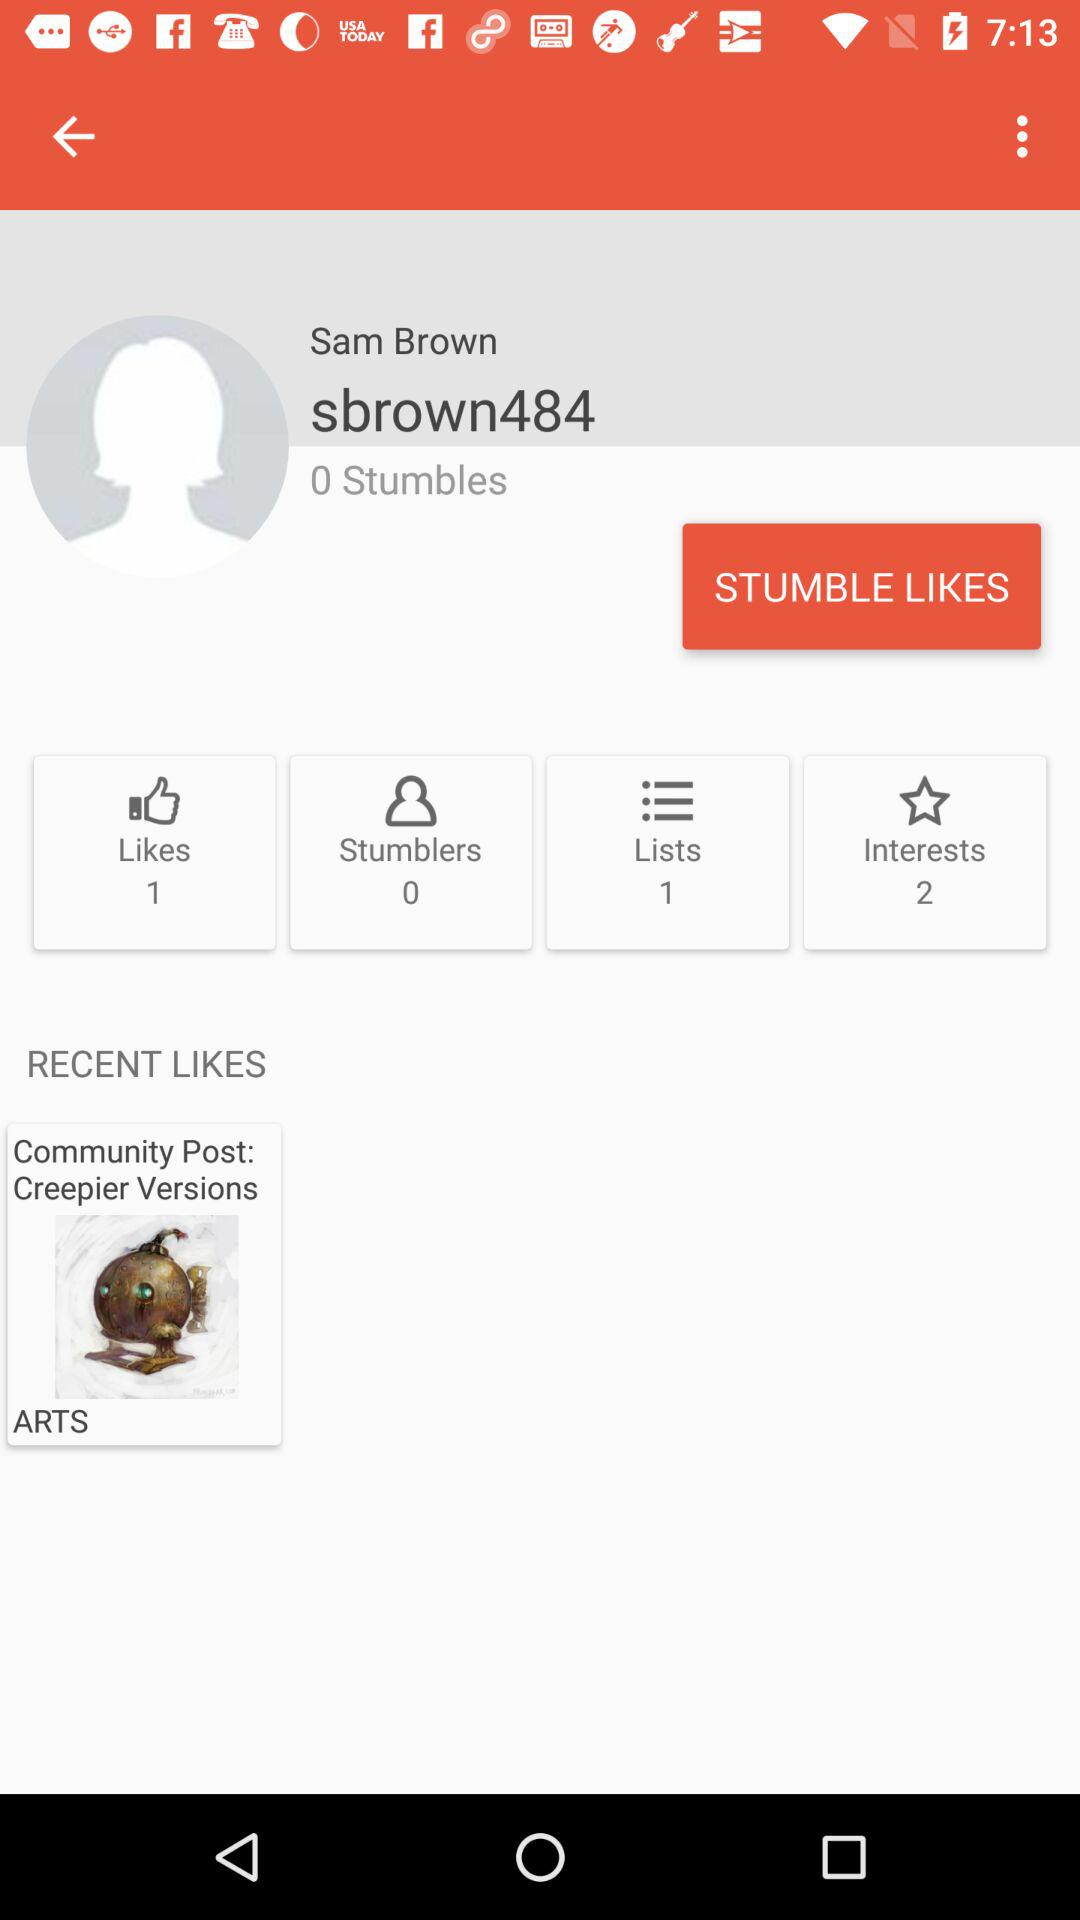How many stumbles are there? There are 0 stumbles. 